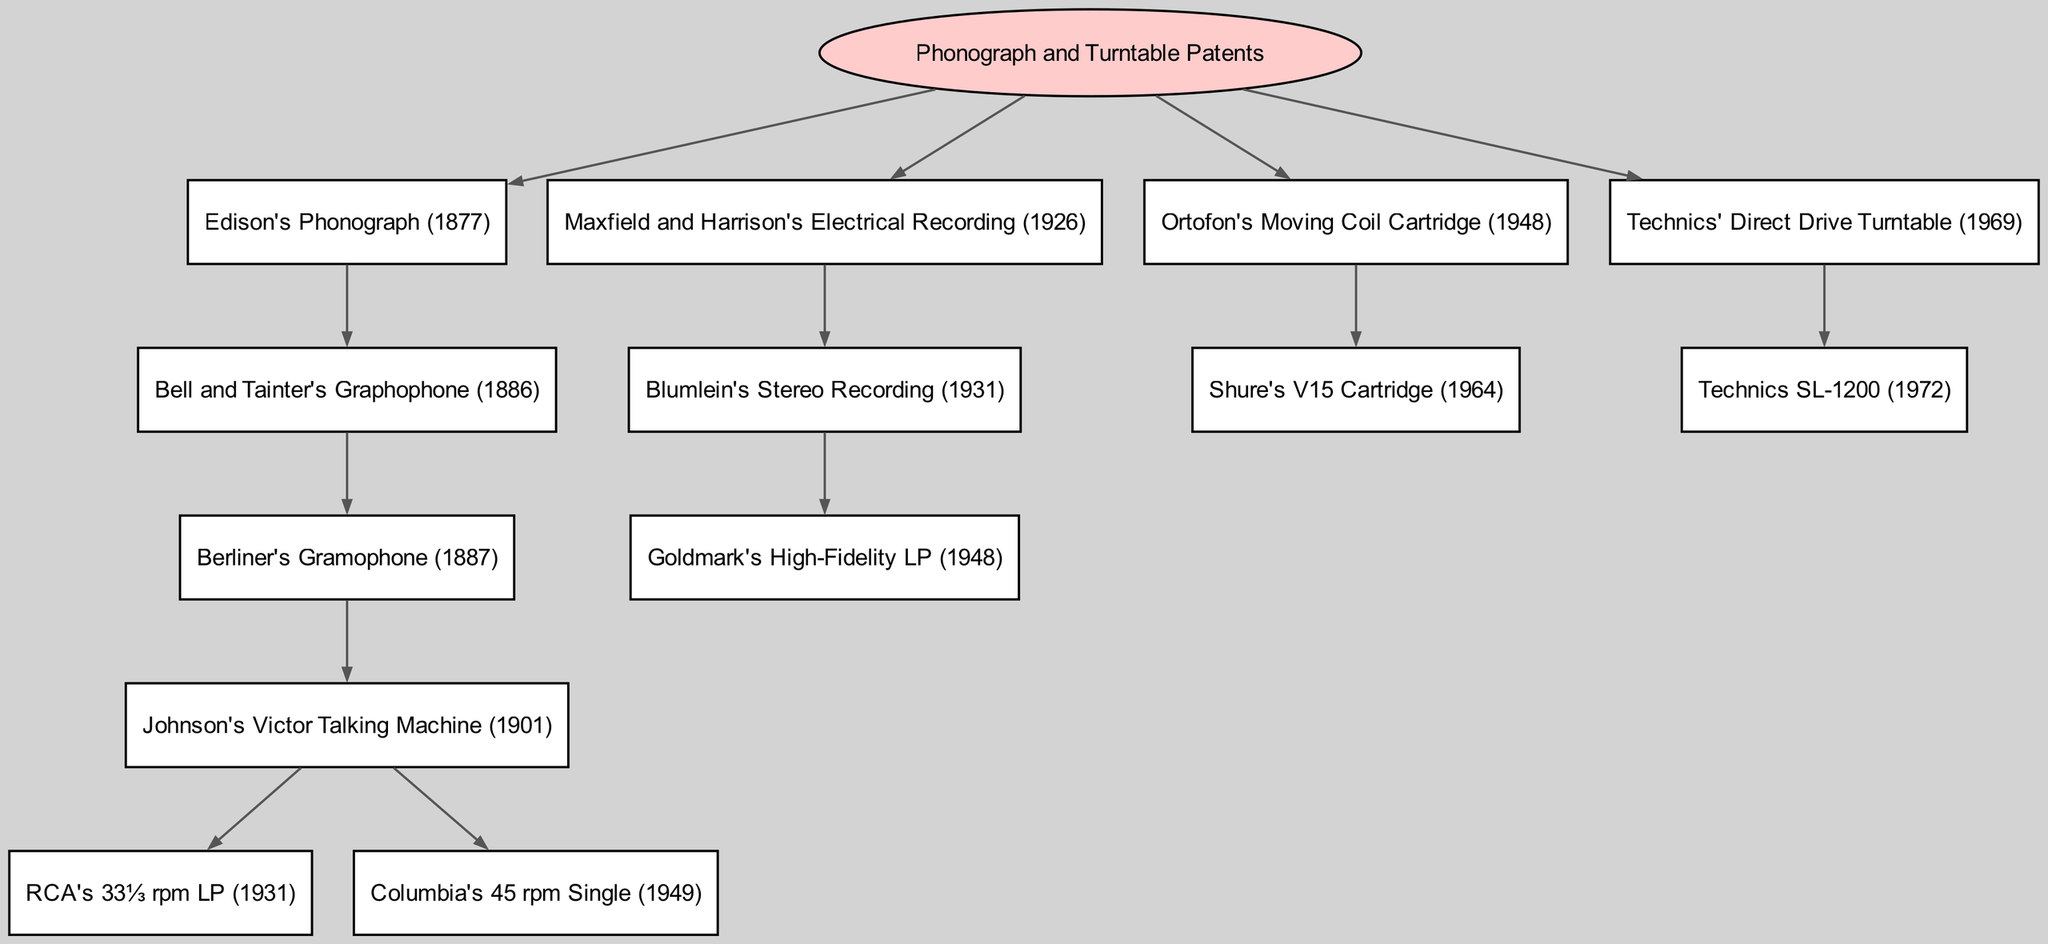What is the root of the family tree? The root of the family tree is the highest level in the diagram, representing the main subject of the tree, which is "Phonograph and Turntable Patents."
Answer: Phonograph and Turntable Patents How many children does Edison's Phonograph have? Edison's Phonograph has one direct child, which is "Bell and Tainter's Graphophone (1886)." This is determined by examining the children of that node.
Answer: 1 What year was the Technics SL-1200 introduced? The Technics SL-1200 is a direct child of "Technics' Direct Drive Turntable (1969)" and was released in the year 1972, which is identified in its title.
Answer: 1972 Which patent is a descendant of both Edison's Phonograph and Maxfield and Harrison's Electrical Recording? To find a common descendant, we trace the branches; however, there is no direct descendant shared by these two patents. Therefore, the answer is indicating that there are no intertwined descendants in this tree.
Answer: None What innovative feature is associated with Ortofon's Moving Coil Cartridge? Ortofon's Moving Coil Cartridge led to the development of Shure's V15 Cartridge (1964), which is known for its advanced sound reproduction capabilities; hence, the innovative feature relates to advancements in cartridge technology associated with that lineage.
Answer: V15 Cartridge How many total patents are listed under the "Edison's Phonograph" branch? Tracing the Edison's Phonograph branch, we count the main node itself, its child "Bell and Tainter's Graphophone (1886)," its child "Berliner's Gramophone (1887)," and its descendant "Johnson's Victor Talking Machine (1901)," leading to a total of 5 patents listed.
Answer: 5 What is the last patent in the family tree chronologically? The last patent in the diagram is "Technics SL-1200 (1972)", which you find by checking the last node at the deepest level of the tree, making it the most recent innovation represented.
Answer: Technics SL-1200 Which patent first introduced the concept of stereo recording? The patent that first introduced the concept of stereo recording in this family tree is "Blumlein's Stereo Recording (1931)," as it is the only one associated with stereo recording technology.
Answer: Blumlein's Stereo Recording What is the relationship between RCA's 33⅓ rpm LP and Johnson's Victor Talking Machine? RCA's 33⅓ rpm LP is a child patent of "Johnson's Victor Talking Machine (1901)," indicating that it is a direct descendant representing a technological advancement stemming from that invention.
Answer: Child What innovative recording format did Columbia introduce in 1949? Columbia introduced the "45 rpm Single" in 1949, which is specifically noted in the relevant branch under "Johnson's Victor Talking Machine."
Answer: 45 rpm Single 